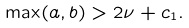<formula> <loc_0><loc_0><loc_500><loc_500>\max ( a , b ) > 2 \nu + c _ { 1 } .</formula> 